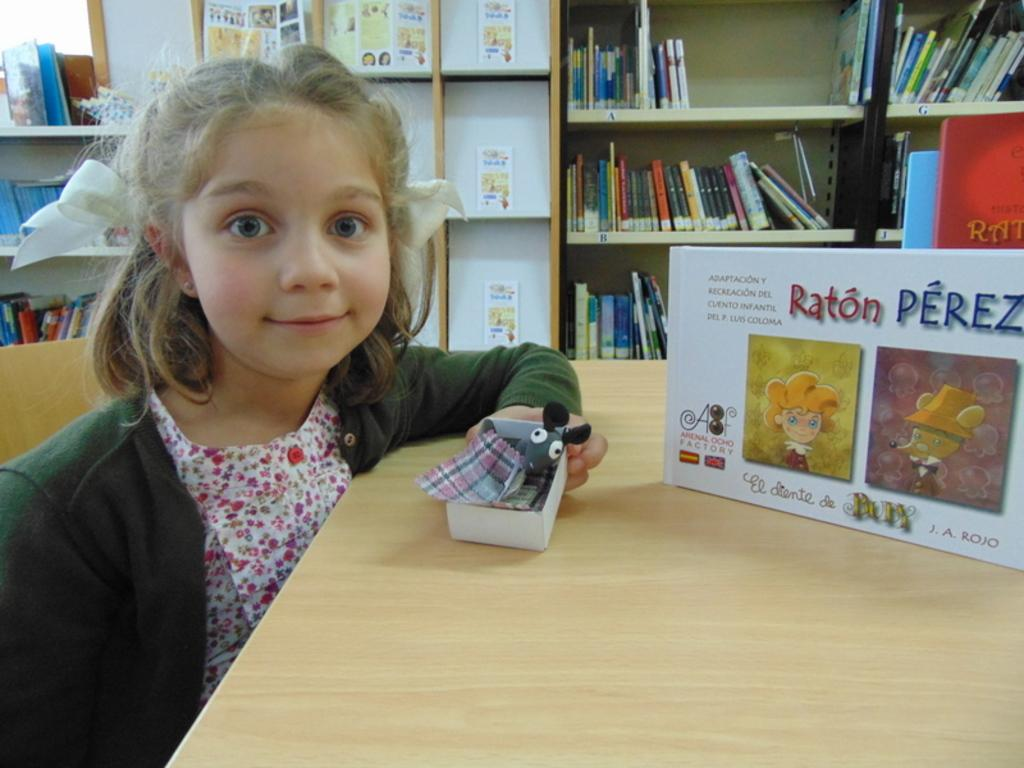<image>
Write a terse but informative summary of the picture. A girl sitting at a table with a box in front of her that says Raton Perez. 